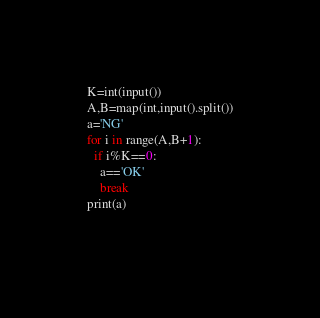<code> <loc_0><loc_0><loc_500><loc_500><_Python_>K=int(input())
A,B=map(int,input().split())
a='NG'
for i in range(A,B+1):
  if i%K==0:
    a=='OK'
    break
print(a)
  </code> 